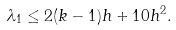Convert formula to latex. <formula><loc_0><loc_0><loc_500><loc_500>\lambda _ { 1 } \leq 2 ( k - 1 ) h + 1 0 h ^ { 2 } .</formula> 